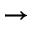<formula> <loc_0><loc_0><loc_500><loc_500>\rightarrow</formula> 